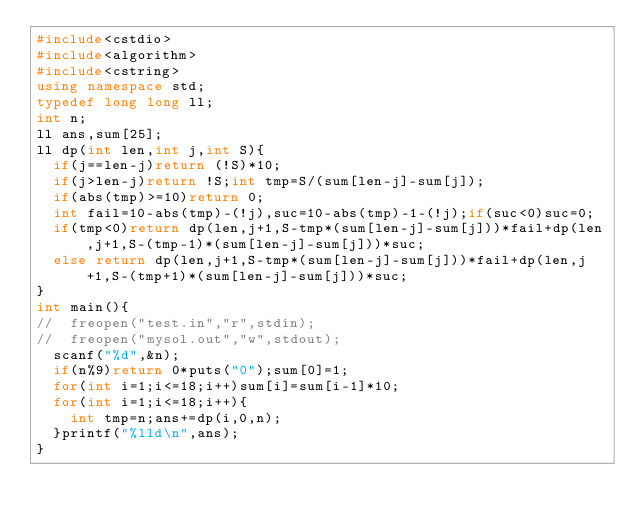Convert code to text. <code><loc_0><loc_0><loc_500><loc_500><_C++_>#include<cstdio>
#include<algorithm>
#include<cstring>
using namespace std;
typedef long long ll;
int n;
ll ans,sum[25];
ll dp(int len,int j,int S){
	if(j==len-j)return (!S)*10;
	if(j>len-j)return !S;int tmp=S/(sum[len-j]-sum[j]);
	if(abs(tmp)>=10)return 0;
	int fail=10-abs(tmp)-(!j),suc=10-abs(tmp)-1-(!j);if(suc<0)suc=0;
	if(tmp<0)return dp(len,j+1,S-tmp*(sum[len-j]-sum[j]))*fail+dp(len,j+1,S-(tmp-1)*(sum[len-j]-sum[j]))*suc;
	else return dp(len,j+1,S-tmp*(sum[len-j]-sum[j]))*fail+dp(len,j+1,S-(tmp+1)*(sum[len-j]-sum[j]))*suc;
}
int main(){
//	freopen("test.in","r",stdin);
//	freopen("mysol.out","w",stdout);
	scanf("%d",&n);
	if(n%9)return 0*puts("0");sum[0]=1;
	for(int i=1;i<=18;i++)sum[i]=sum[i-1]*10;
	for(int i=1;i<=18;i++){
		int tmp=n;ans+=dp(i,0,n);
	}printf("%lld\n",ans);
}
</code> 